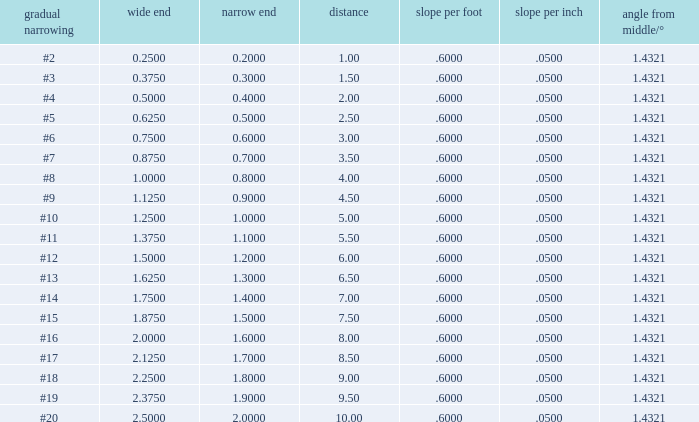Which Taper/in that has a Small end larger than 0.7000000000000001, and a Taper of #19, and a Large end larger than 2.375? None. 